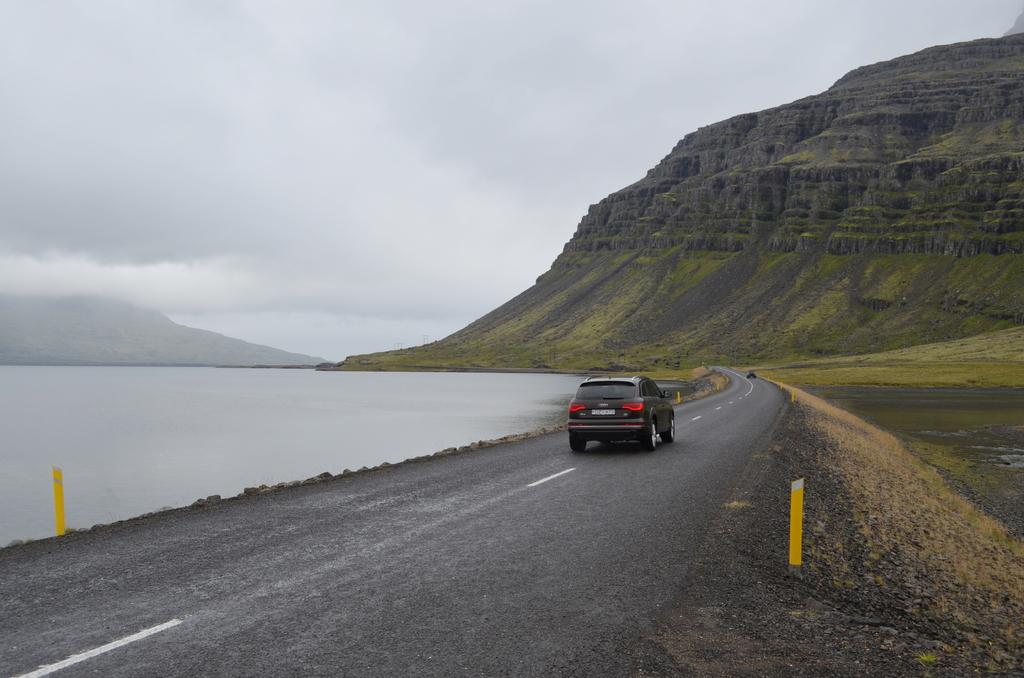What color is the car in the image? The car in the image is black. What is the car doing in the image? The car is moving on the road. What can be seen in the background of the image? There is water, grassland, hills, and a cloudy sky visible in the background. What type of shade is provided by the car in the image? There is no shade provided by the car in the image, as it is moving on the road. Can you see any waves in the water visible in the background? There are no waves visible in the water in the background, as the water appears to be still. 